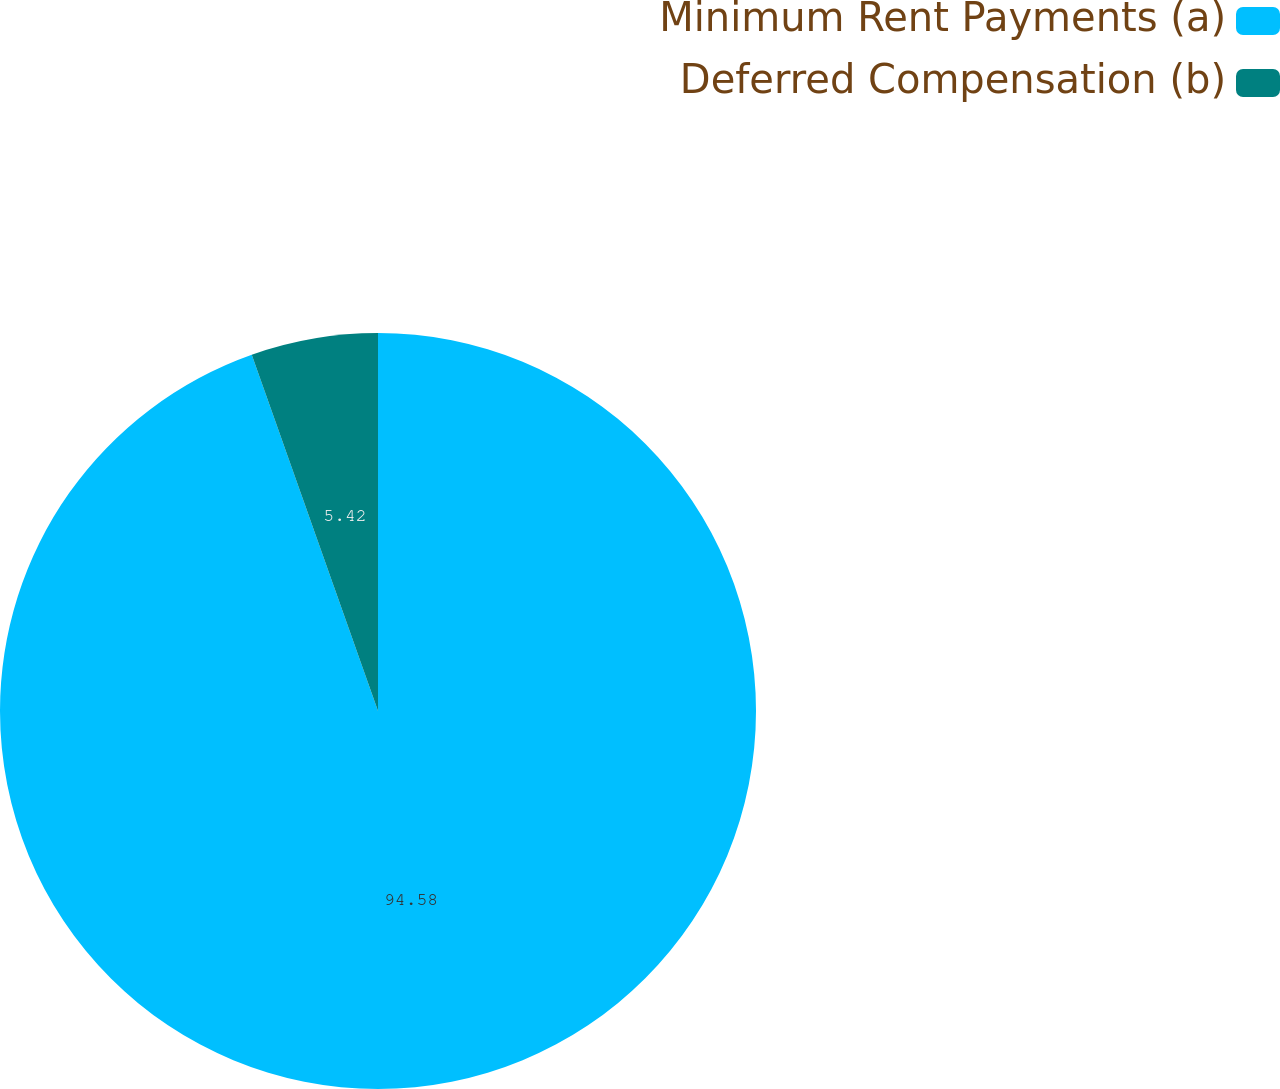Convert chart. <chart><loc_0><loc_0><loc_500><loc_500><pie_chart><fcel>Minimum Rent Payments (a)<fcel>Deferred Compensation (b)<nl><fcel>94.58%<fcel>5.42%<nl></chart> 